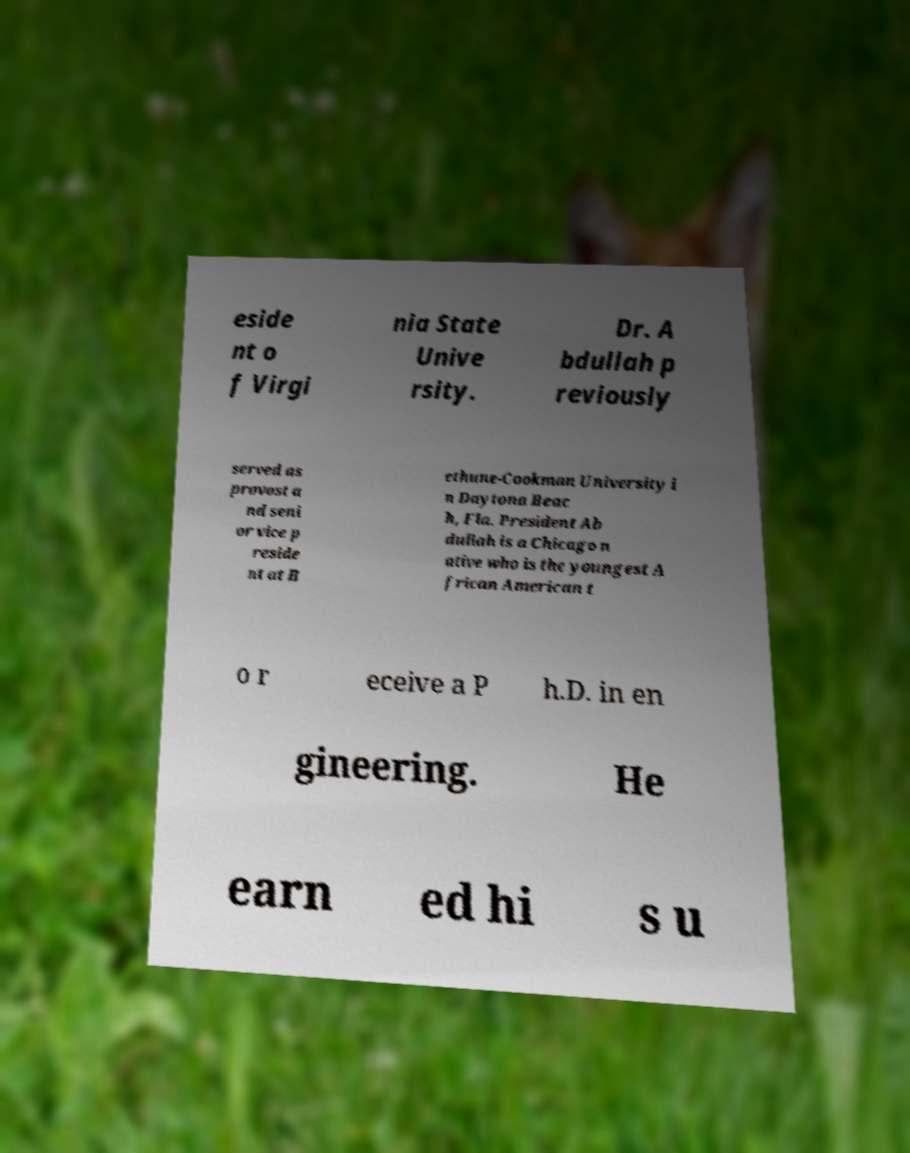Please read and relay the text visible in this image. What does it say? eside nt o f Virgi nia State Unive rsity. Dr. A bdullah p reviously served as provost a nd seni or vice p reside nt at B ethune-Cookman University i n Daytona Beac h, Fla. President Ab dullah is a Chicago n ative who is the youngest A frican American t o r eceive a P h.D. in en gineering. He earn ed hi s u 